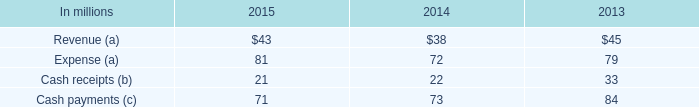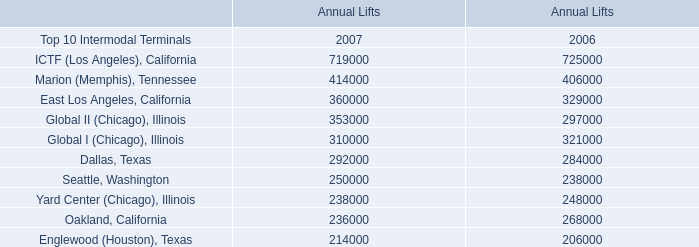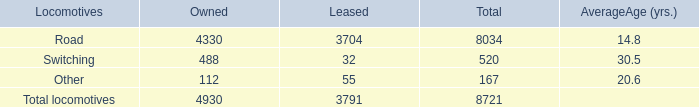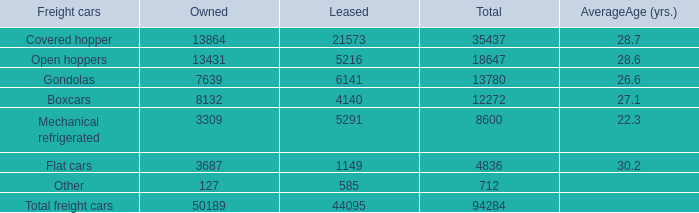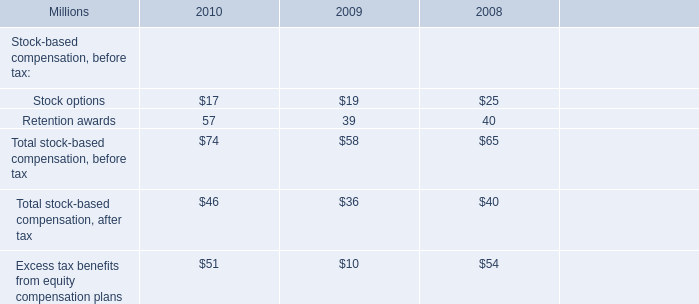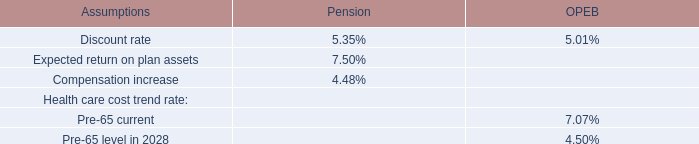What was the total amount of Locomotives greater than 300 in for owned? 
Computations: (4330 + 488)
Answer: 4818.0. 